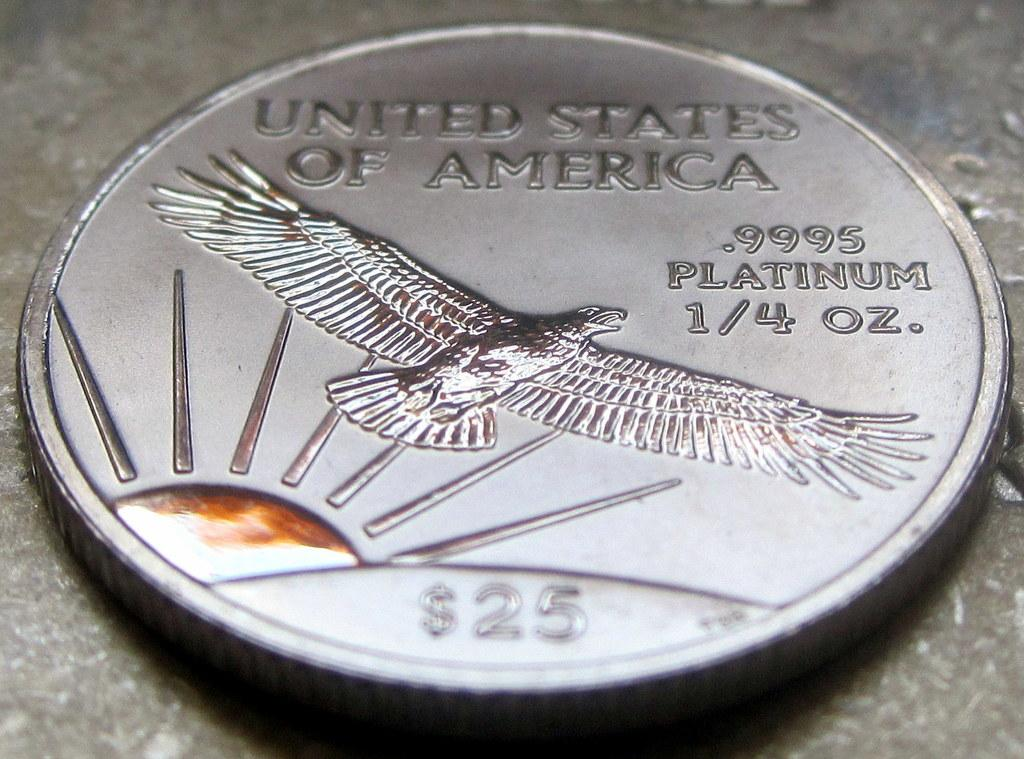<image>
Present a compact description of the photo's key features. The impressive coin is worth $25 dollars in America. 